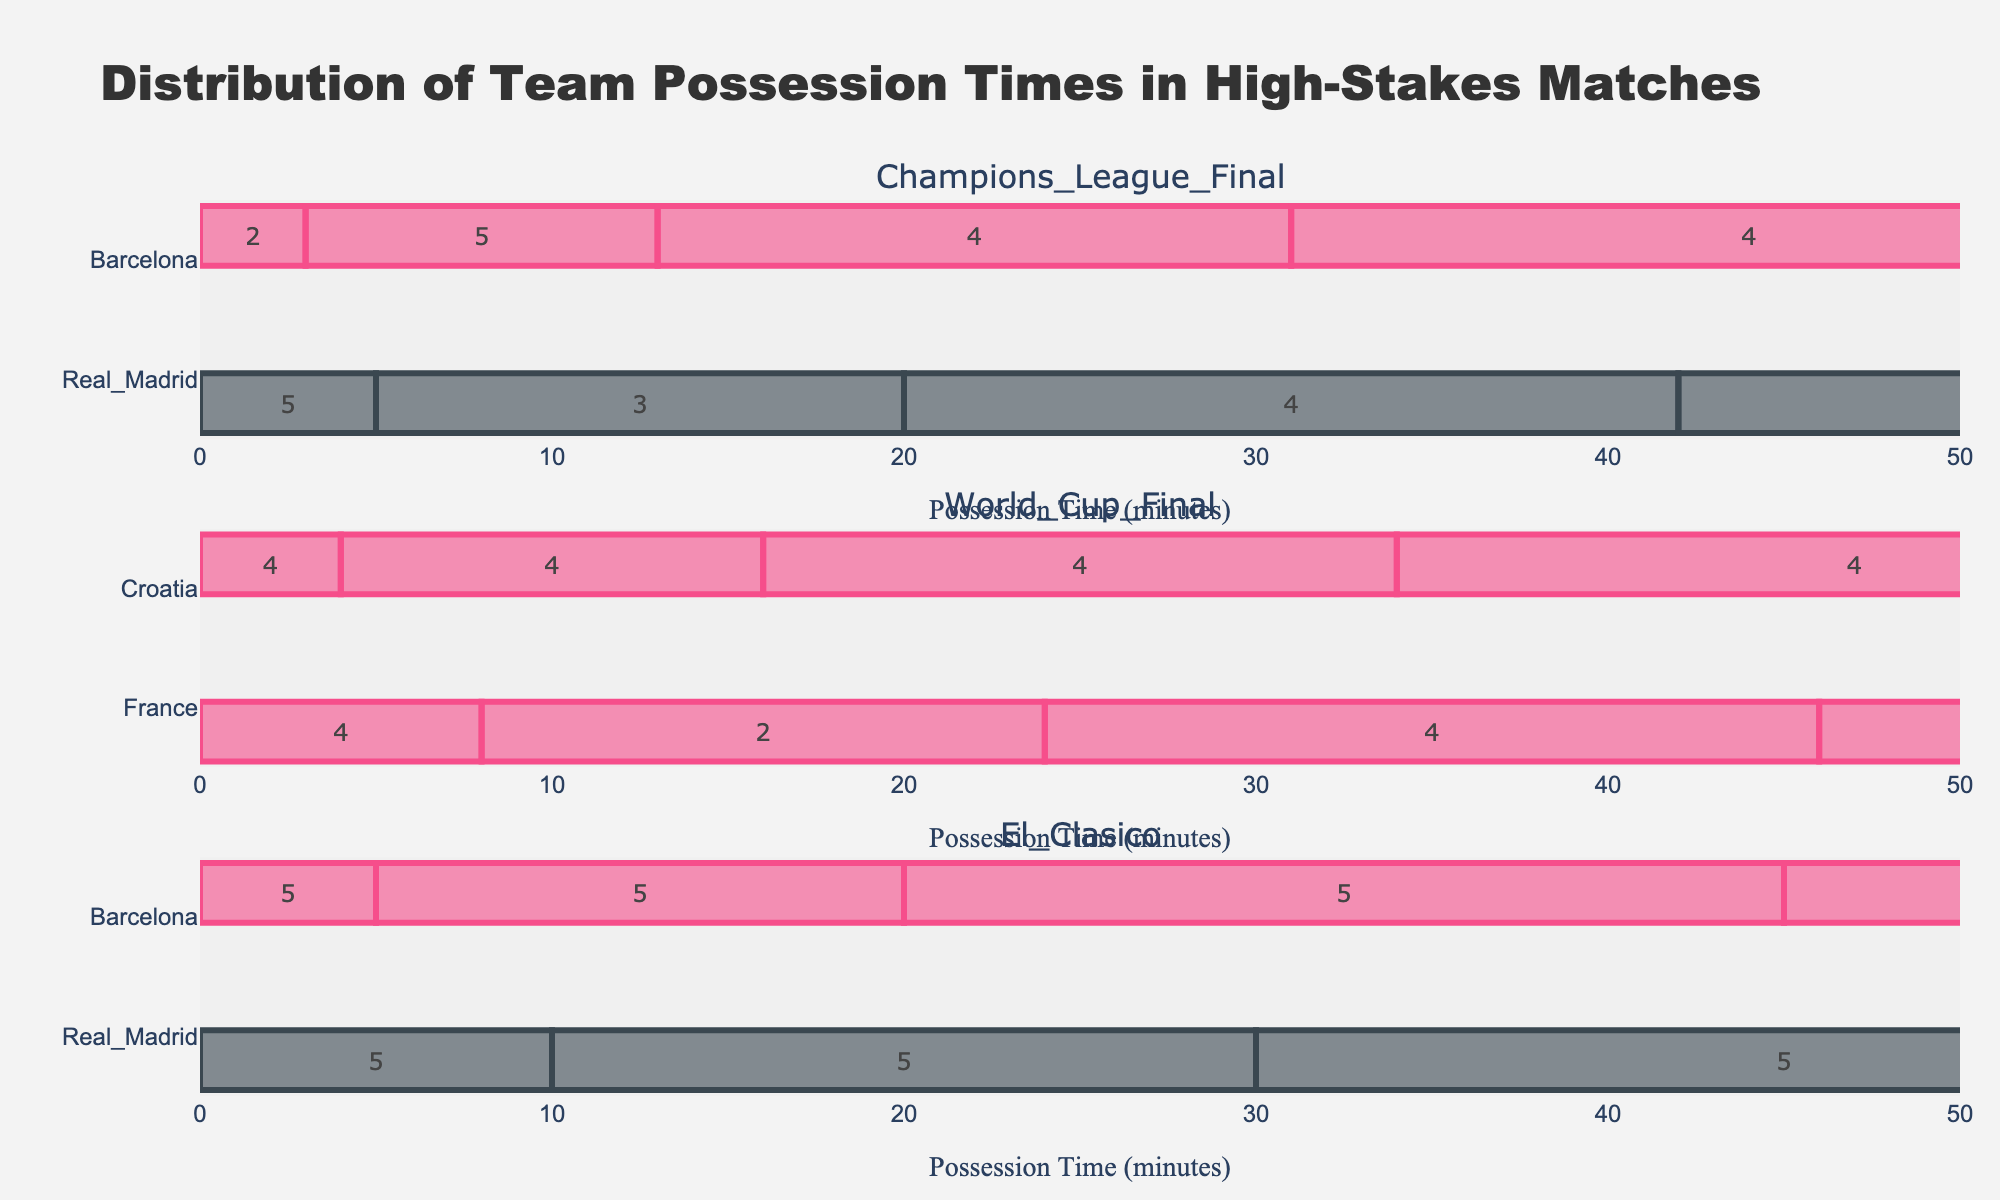What is the title of the figure? The title of the figure is typically found at the top of the plot. Here, it is "Distribution of Team Possession Times in High-Stakes Matches".
Answer: Distribution of Team Possession Times in High-Stakes Matches Which teams are represented in the Champions League Final? Each match has different teams with their possessions represented. For the Champions League Final, the teams are Real Madrid and Barcelona.
Answer: Real Madrid, Barcelona How long was Real Madrid's longest possession in the Champions League Final? To find the longest possession, look for the widest bar corresponding to Real Madrid within the Champions League Final subplot. Real Madrid's longest possession lasts from minute 5 to minute 10. The duration is 10 - 5 = 5 minutes.
Answer: 5 minutes What is the color used to represent Barcelona's possessions? The color representing each team is shown in the bars on the figure. For Barcelona, the bars are colored in a shade of pink.
Answer: Pink Compare the average possession time of Real Madrid and Barcelona in El Clasico. First, calculate each team's possession durations in El Clasico. For Real Madrid: (5-0) + (15-10) + (25-20) + (35-30) + (45-40) = 25 minutes. For Barcelona: (10-5) + (20-15) + (30-25) + (40-35) + (50-45) = 25 minutes. To find the average, divide by the number of possessions, which is 5 for both teams. Therefore, the average possession time for both Real Madrid and Barcelona is 25 / 5 = 5 minutes.
Answer: 5 minutes each How do France's possession durations in the World Cup Final compare with Croatia's? To compare, sum the possession times for both teams in the World Cup Final. For France: (4-0) + (12-8) + (18-16) + (26-22) + (34-30) + (45-38) = 4 + 4 + 2 + 4 + 4 + 7 = 25 minutes. For Croatia: (8-4) + (16-12) + (22-18) + (30-26) + (38-34) + (50-45) = 4 + 4 + 4 + 4 + 4 + 5 = 25 minutes. Both teams have a total possession time of 25 minutes.
Answer: Equal, 25 minutes each Which match had the most balanced possession times between the two teams? To determine this, compare the sum of possession times for each team in each match. In the Champions League Final, Real Madrid and Barcelona both have equal possessions of 22 minutes each. In the World Cup Final, France and Croatia both have possessions of 25 minutes each. In El Clasico, Real Madrid and Barcelona both have possessions of 25 minutes each. Hence, multiple matches are equally balanced.
Answer: All matches What was the possession duration difference between Real Madrid and Barcelona in the Champions League Final? Calculate the total possessions for Real Madrid and Barcelona in the Champions League Final. For Real Madrid: (3-0) + (10-5) + (18-15) + (26-22) + (33-30) + (38-36) = 3 + 5 + 3 + 4 + 3 + 2 = 20 minutes. For Barcelona: (5-3) + (15-10) + (22-18) + (30-26) + (36-33) + (42-38) = 2 + 5 + 4 + 4 + 3 + 4 = 22 minutes. The possession duration difference is 22 - 20 = 2 minutes.
Answer: 2 minutes Which team had the last possession in El Clasico, and how long did it last? Look at the last bar in the subplot for El Clasico. It belongs to Barcelona and lasts from minute 45 to minute 50, which means the possession duration is 50 - 45 = 5 minutes.
Answer: Barcelona, 5 minutes 